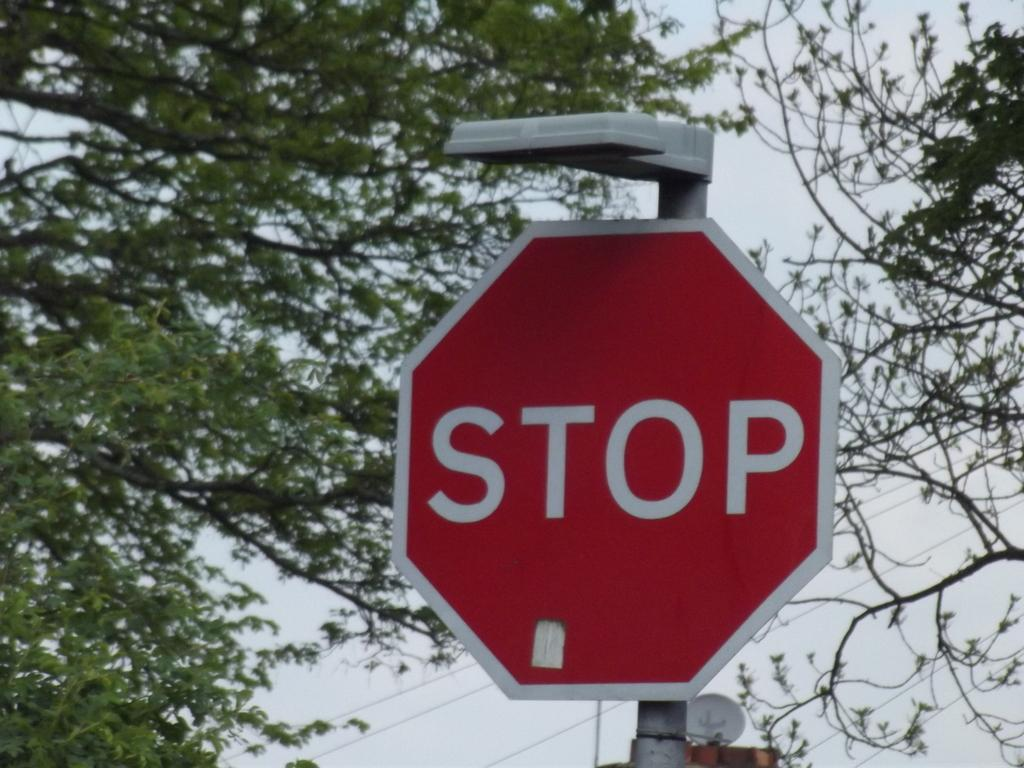<image>
Render a clear and concise summary of the photo. A red stop sign with a light on top of it 